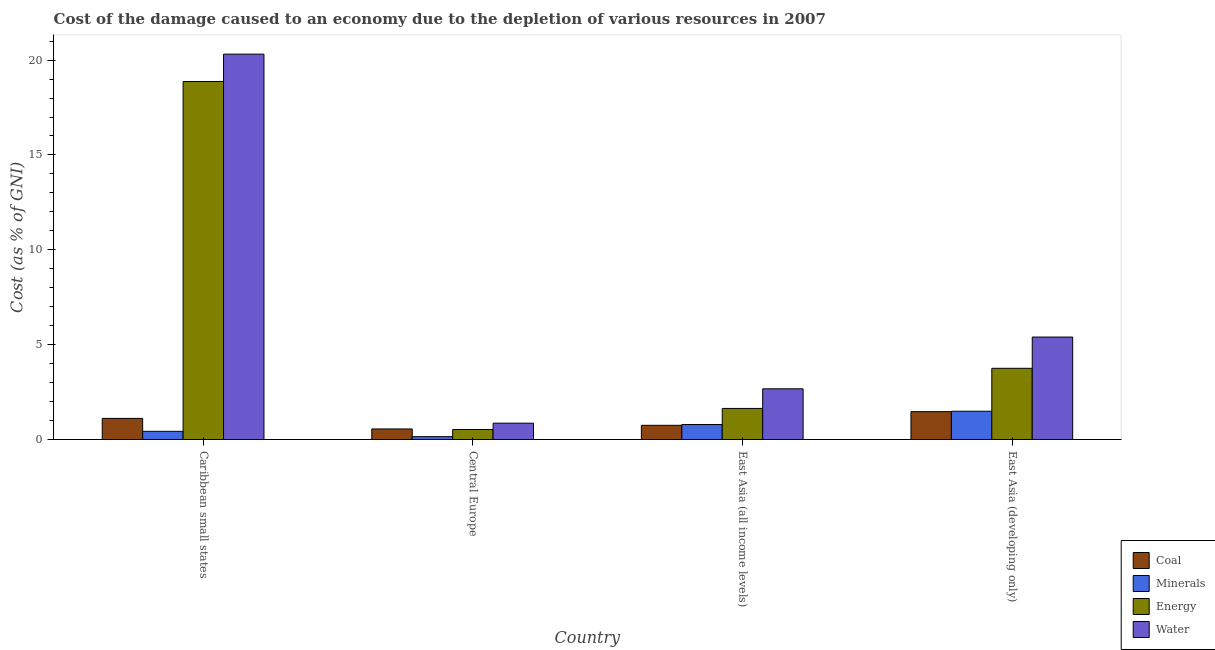How many different coloured bars are there?
Offer a very short reply. 4. How many groups of bars are there?
Offer a terse response. 4. How many bars are there on the 3rd tick from the left?
Your answer should be very brief. 4. What is the label of the 2nd group of bars from the left?
Offer a terse response. Central Europe. In how many cases, is the number of bars for a given country not equal to the number of legend labels?
Ensure brevity in your answer.  0. What is the cost of damage due to depletion of coal in East Asia (developing only)?
Offer a very short reply. 1.47. Across all countries, what is the maximum cost of damage due to depletion of minerals?
Give a very brief answer. 1.49. Across all countries, what is the minimum cost of damage due to depletion of minerals?
Offer a very short reply. 0.15. In which country was the cost of damage due to depletion of coal maximum?
Keep it short and to the point. East Asia (developing only). In which country was the cost of damage due to depletion of water minimum?
Give a very brief answer. Central Europe. What is the total cost of damage due to depletion of coal in the graph?
Give a very brief answer. 3.89. What is the difference between the cost of damage due to depletion of energy in Caribbean small states and that in East Asia (developing only)?
Provide a short and direct response. 15.12. What is the difference between the cost of damage due to depletion of coal in East Asia (developing only) and the cost of damage due to depletion of minerals in Caribbean small states?
Provide a short and direct response. 1.04. What is the average cost of damage due to depletion of energy per country?
Make the answer very short. 6.2. What is the difference between the cost of damage due to depletion of energy and cost of damage due to depletion of minerals in East Asia (developing only)?
Make the answer very short. 2.26. In how many countries, is the cost of damage due to depletion of minerals greater than 20 %?
Provide a succinct answer. 0. What is the ratio of the cost of damage due to depletion of water in Caribbean small states to that in East Asia (developing only)?
Your answer should be very brief. 3.76. Is the difference between the cost of damage due to depletion of water in Central Europe and East Asia (developing only) greater than the difference between the cost of damage due to depletion of coal in Central Europe and East Asia (developing only)?
Offer a very short reply. No. What is the difference between the highest and the second highest cost of damage due to depletion of water?
Ensure brevity in your answer.  14.91. What is the difference between the highest and the lowest cost of damage due to depletion of water?
Give a very brief answer. 19.45. Is the sum of the cost of damage due to depletion of water in Caribbean small states and East Asia (all income levels) greater than the maximum cost of damage due to depletion of coal across all countries?
Give a very brief answer. Yes. Is it the case that in every country, the sum of the cost of damage due to depletion of water and cost of damage due to depletion of coal is greater than the sum of cost of damage due to depletion of energy and cost of damage due to depletion of minerals?
Make the answer very short. No. What does the 4th bar from the left in East Asia (developing only) represents?
Provide a short and direct response. Water. What does the 1st bar from the right in East Asia (developing only) represents?
Make the answer very short. Water. How many countries are there in the graph?
Offer a very short reply. 4. Does the graph contain any zero values?
Your answer should be compact. No. Where does the legend appear in the graph?
Your answer should be very brief. Bottom right. How many legend labels are there?
Provide a succinct answer. 4. How are the legend labels stacked?
Offer a terse response. Vertical. What is the title of the graph?
Make the answer very short. Cost of the damage caused to an economy due to the depletion of various resources in 2007 . What is the label or title of the X-axis?
Your response must be concise. Country. What is the label or title of the Y-axis?
Make the answer very short. Cost (as % of GNI). What is the Cost (as % of GNI) in Coal in Caribbean small states?
Keep it short and to the point. 1.11. What is the Cost (as % of GNI) in Minerals in Caribbean small states?
Your answer should be very brief. 0.43. What is the Cost (as % of GNI) of Energy in Caribbean small states?
Ensure brevity in your answer.  18.87. What is the Cost (as % of GNI) in Water in Caribbean small states?
Make the answer very short. 20.31. What is the Cost (as % of GNI) in Coal in Central Europe?
Give a very brief answer. 0.56. What is the Cost (as % of GNI) in Minerals in Central Europe?
Offer a terse response. 0.15. What is the Cost (as % of GNI) of Energy in Central Europe?
Give a very brief answer. 0.53. What is the Cost (as % of GNI) of Water in Central Europe?
Your answer should be compact. 0.86. What is the Cost (as % of GNI) in Coal in East Asia (all income levels)?
Your answer should be compact. 0.75. What is the Cost (as % of GNI) of Minerals in East Asia (all income levels)?
Offer a terse response. 0.79. What is the Cost (as % of GNI) in Energy in East Asia (all income levels)?
Keep it short and to the point. 1.64. What is the Cost (as % of GNI) in Water in East Asia (all income levels)?
Offer a very short reply. 2.67. What is the Cost (as % of GNI) of Coal in East Asia (developing only)?
Offer a terse response. 1.47. What is the Cost (as % of GNI) of Minerals in East Asia (developing only)?
Offer a very short reply. 1.49. What is the Cost (as % of GNI) of Energy in East Asia (developing only)?
Your answer should be very brief. 3.75. What is the Cost (as % of GNI) in Water in East Asia (developing only)?
Provide a succinct answer. 5.4. Across all countries, what is the maximum Cost (as % of GNI) of Coal?
Offer a very short reply. 1.47. Across all countries, what is the maximum Cost (as % of GNI) of Minerals?
Your response must be concise. 1.49. Across all countries, what is the maximum Cost (as % of GNI) in Energy?
Ensure brevity in your answer.  18.87. Across all countries, what is the maximum Cost (as % of GNI) in Water?
Ensure brevity in your answer.  20.31. Across all countries, what is the minimum Cost (as % of GNI) of Coal?
Keep it short and to the point. 0.56. Across all countries, what is the minimum Cost (as % of GNI) of Minerals?
Ensure brevity in your answer.  0.15. Across all countries, what is the minimum Cost (as % of GNI) of Energy?
Ensure brevity in your answer.  0.53. Across all countries, what is the minimum Cost (as % of GNI) of Water?
Offer a very short reply. 0.86. What is the total Cost (as % of GNI) of Coal in the graph?
Your answer should be very brief. 3.89. What is the total Cost (as % of GNI) in Minerals in the graph?
Your response must be concise. 2.87. What is the total Cost (as % of GNI) in Energy in the graph?
Ensure brevity in your answer.  24.79. What is the total Cost (as % of GNI) in Water in the graph?
Provide a short and direct response. 29.25. What is the difference between the Cost (as % of GNI) in Coal in Caribbean small states and that in Central Europe?
Your answer should be compact. 0.56. What is the difference between the Cost (as % of GNI) in Minerals in Caribbean small states and that in Central Europe?
Provide a short and direct response. 0.28. What is the difference between the Cost (as % of GNI) of Energy in Caribbean small states and that in Central Europe?
Offer a terse response. 18.35. What is the difference between the Cost (as % of GNI) of Water in Caribbean small states and that in Central Europe?
Provide a short and direct response. 19.45. What is the difference between the Cost (as % of GNI) of Coal in Caribbean small states and that in East Asia (all income levels)?
Your answer should be very brief. 0.36. What is the difference between the Cost (as % of GNI) in Minerals in Caribbean small states and that in East Asia (all income levels)?
Make the answer very short. -0.36. What is the difference between the Cost (as % of GNI) in Energy in Caribbean small states and that in East Asia (all income levels)?
Keep it short and to the point. 17.23. What is the difference between the Cost (as % of GNI) in Water in Caribbean small states and that in East Asia (all income levels)?
Your response must be concise. 17.64. What is the difference between the Cost (as % of GNI) of Coal in Caribbean small states and that in East Asia (developing only)?
Provide a succinct answer. -0.36. What is the difference between the Cost (as % of GNI) in Minerals in Caribbean small states and that in East Asia (developing only)?
Give a very brief answer. -1.06. What is the difference between the Cost (as % of GNI) in Energy in Caribbean small states and that in East Asia (developing only)?
Your response must be concise. 15.12. What is the difference between the Cost (as % of GNI) of Water in Caribbean small states and that in East Asia (developing only)?
Offer a very short reply. 14.91. What is the difference between the Cost (as % of GNI) of Coal in Central Europe and that in East Asia (all income levels)?
Your answer should be compact. -0.19. What is the difference between the Cost (as % of GNI) of Minerals in Central Europe and that in East Asia (all income levels)?
Your response must be concise. -0.64. What is the difference between the Cost (as % of GNI) in Energy in Central Europe and that in East Asia (all income levels)?
Your response must be concise. -1.11. What is the difference between the Cost (as % of GNI) in Water in Central Europe and that in East Asia (all income levels)?
Keep it short and to the point. -1.81. What is the difference between the Cost (as % of GNI) in Coal in Central Europe and that in East Asia (developing only)?
Give a very brief answer. -0.91. What is the difference between the Cost (as % of GNI) of Minerals in Central Europe and that in East Asia (developing only)?
Your answer should be compact. -1.34. What is the difference between the Cost (as % of GNI) in Energy in Central Europe and that in East Asia (developing only)?
Offer a terse response. -3.23. What is the difference between the Cost (as % of GNI) in Water in Central Europe and that in East Asia (developing only)?
Give a very brief answer. -4.54. What is the difference between the Cost (as % of GNI) of Coal in East Asia (all income levels) and that in East Asia (developing only)?
Keep it short and to the point. -0.72. What is the difference between the Cost (as % of GNI) of Energy in East Asia (all income levels) and that in East Asia (developing only)?
Your response must be concise. -2.12. What is the difference between the Cost (as % of GNI) of Water in East Asia (all income levels) and that in East Asia (developing only)?
Ensure brevity in your answer.  -2.73. What is the difference between the Cost (as % of GNI) of Coal in Caribbean small states and the Cost (as % of GNI) of Minerals in Central Europe?
Give a very brief answer. 0.96. What is the difference between the Cost (as % of GNI) in Coal in Caribbean small states and the Cost (as % of GNI) in Energy in Central Europe?
Give a very brief answer. 0.59. What is the difference between the Cost (as % of GNI) of Coal in Caribbean small states and the Cost (as % of GNI) of Water in Central Europe?
Your answer should be very brief. 0.25. What is the difference between the Cost (as % of GNI) of Minerals in Caribbean small states and the Cost (as % of GNI) of Energy in Central Europe?
Make the answer very short. -0.1. What is the difference between the Cost (as % of GNI) in Minerals in Caribbean small states and the Cost (as % of GNI) in Water in Central Europe?
Offer a very short reply. -0.43. What is the difference between the Cost (as % of GNI) in Energy in Caribbean small states and the Cost (as % of GNI) in Water in Central Europe?
Your answer should be very brief. 18.01. What is the difference between the Cost (as % of GNI) of Coal in Caribbean small states and the Cost (as % of GNI) of Minerals in East Asia (all income levels)?
Keep it short and to the point. 0.32. What is the difference between the Cost (as % of GNI) of Coal in Caribbean small states and the Cost (as % of GNI) of Energy in East Asia (all income levels)?
Your answer should be very brief. -0.53. What is the difference between the Cost (as % of GNI) of Coal in Caribbean small states and the Cost (as % of GNI) of Water in East Asia (all income levels)?
Offer a terse response. -1.56. What is the difference between the Cost (as % of GNI) of Minerals in Caribbean small states and the Cost (as % of GNI) of Energy in East Asia (all income levels)?
Ensure brevity in your answer.  -1.21. What is the difference between the Cost (as % of GNI) of Minerals in Caribbean small states and the Cost (as % of GNI) of Water in East Asia (all income levels)?
Make the answer very short. -2.24. What is the difference between the Cost (as % of GNI) of Energy in Caribbean small states and the Cost (as % of GNI) of Water in East Asia (all income levels)?
Your answer should be very brief. 16.2. What is the difference between the Cost (as % of GNI) in Coal in Caribbean small states and the Cost (as % of GNI) in Minerals in East Asia (developing only)?
Offer a very short reply. -0.38. What is the difference between the Cost (as % of GNI) in Coal in Caribbean small states and the Cost (as % of GNI) in Energy in East Asia (developing only)?
Offer a terse response. -2.64. What is the difference between the Cost (as % of GNI) in Coal in Caribbean small states and the Cost (as % of GNI) in Water in East Asia (developing only)?
Keep it short and to the point. -4.29. What is the difference between the Cost (as % of GNI) of Minerals in Caribbean small states and the Cost (as % of GNI) of Energy in East Asia (developing only)?
Give a very brief answer. -3.32. What is the difference between the Cost (as % of GNI) of Minerals in Caribbean small states and the Cost (as % of GNI) of Water in East Asia (developing only)?
Your response must be concise. -4.97. What is the difference between the Cost (as % of GNI) in Energy in Caribbean small states and the Cost (as % of GNI) in Water in East Asia (developing only)?
Offer a very short reply. 13.47. What is the difference between the Cost (as % of GNI) of Coal in Central Europe and the Cost (as % of GNI) of Minerals in East Asia (all income levels)?
Make the answer very short. -0.23. What is the difference between the Cost (as % of GNI) of Coal in Central Europe and the Cost (as % of GNI) of Energy in East Asia (all income levels)?
Give a very brief answer. -1.08. What is the difference between the Cost (as % of GNI) of Coal in Central Europe and the Cost (as % of GNI) of Water in East Asia (all income levels)?
Your answer should be compact. -2.12. What is the difference between the Cost (as % of GNI) of Minerals in Central Europe and the Cost (as % of GNI) of Energy in East Asia (all income levels)?
Offer a terse response. -1.49. What is the difference between the Cost (as % of GNI) of Minerals in Central Europe and the Cost (as % of GNI) of Water in East Asia (all income levels)?
Offer a very short reply. -2.52. What is the difference between the Cost (as % of GNI) of Energy in Central Europe and the Cost (as % of GNI) of Water in East Asia (all income levels)?
Provide a succinct answer. -2.15. What is the difference between the Cost (as % of GNI) of Coal in Central Europe and the Cost (as % of GNI) of Minerals in East Asia (developing only)?
Your response must be concise. -0.93. What is the difference between the Cost (as % of GNI) in Coal in Central Europe and the Cost (as % of GNI) in Energy in East Asia (developing only)?
Provide a succinct answer. -3.2. What is the difference between the Cost (as % of GNI) in Coal in Central Europe and the Cost (as % of GNI) in Water in East Asia (developing only)?
Your answer should be compact. -4.84. What is the difference between the Cost (as % of GNI) in Minerals in Central Europe and the Cost (as % of GNI) in Energy in East Asia (developing only)?
Offer a very short reply. -3.6. What is the difference between the Cost (as % of GNI) in Minerals in Central Europe and the Cost (as % of GNI) in Water in East Asia (developing only)?
Your answer should be compact. -5.25. What is the difference between the Cost (as % of GNI) of Energy in Central Europe and the Cost (as % of GNI) of Water in East Asia (developing only)?
Give a very brief answer. -4.87. What is the difference between the Cost (as % of GNI) in Coal in East Asia (all income levels) and the Cost (as % of GNI) in Minerals in East Asia (developing only)?
Your answer should be compact. -0.74. What is the difference between the Cost (as % of GNI) in Coal in East Asia (all income levels) and the Cost (as % of GNI) in Energy in East Asia (developing only)?
Give a very brief answer. -3.01. What is the difference between the Cost (as % of GNI) of Coal in East Asia (all income levels) and the Cost (as % of GNI) of Water in East Asia (developing only)?
Give a very brief answer. -4.65. What is the difference between the Cost (as % of GNI) in Minerals in East Asia (all income levels) and the Cost (as % of GNI) in Energy in East Asia (developing only)?
Keep it short and to the point. -2.96. What is the difference between the Cost (as % of GNI) of Minerals in East Asia (all income levels) and the Cost (as % of GNI) of Water in East Asia (developing only)?
Make the answer very short. -4.61. What is the difference between the Cost (as % of GNI) of Energy in East Asia (all income levels) and the Cost (as % of GNI) of Water in East Asia (developing only)?
Your answer should be very brief. -3.76. What is the average Cost (as % of GNI) of Coal per country?
Provide a short and direct response. 0.97. What is the average Cost (as % of GNI) of Minerals per country?
Keep it short and to the point. 0.72. What is the average Cost (as % of GNI) of Energy per country?
Your answer should be very brief. 6.2. What is the average Cost (as % of GNI) of Water per country?
Make the answer very short. 7.31. What is the difference between the Cost (as % of GNI) of Coal and Cost (as % of GNI) of Minerals in Caribbean small states?
Offer a terse response. 0.68. What is the difference between the Cost (as % of GNI) in Coal and Cost (as % of GNI) in Energy in Caribbean small states?
Keep it short and to the point. -17.76. What is the difference between the Cost (as % of GNI) of Coal and Cost (as % of GNI) of Water in Caribbean small states?
Provide a short and direct response. -19.2. What is the difference between the Cost (as % of GNI) in Minerals and Cost (as % of GNI) in Energy in Caribbean small states?
Give a very brief answer. -18.44. What is the difference between the Cost (as % of GNI) in Minerals and Cost (as % of GNI) in Water in Caribbean small states?
Your answer should be compact. -19.88. What is the difference between the Cost (as % of GNI) in Energy and Cost (as % of GNI) in Water in Caribbean small states?
Provide a short and direct response. -1.44. What is the difference between the Cost (as % of GNI) of Coal and Cost (as % of GNI) of Minerals in Central Europe?
Offer a very short reply. 0.41. What is the difference between the Cost (as % of GNI) in Coal and Cost (as % of GNI) in Energy in Central Europe?
Offer a very short reply. 0.03. What is the difference between the Cost (as % of GNI) in Coal and Cost (as % of GNI) in Water in Central Europe?
Give a very brief answer. -0.3. What is the difference between the Cost (as % of GNI) in Minerals and Cost (as % of GNI) in Energy in Central Europe?
Your answer should be compact. -0.38. What is the difference between the Cost (as % of GNI) in Minerals and Cost (as % of GNI) in Water in Central Europe?
Provide a succinct answer. -0.71. What is the difference between the Cost (as % of GNI) in Energy and Cost (as % of GNI) in Water in Central Europe?
Keep it short and to the point. -0.33. What is the difference between the Cost (as % of GNI) of Coal and Cost (as % of GNI) of Minerals in East Asia (all income levels)?
Give a very brief answer. -0.04. What is the difference between the Cost (as % of GNI) in Coal and Cost (as % of GNI) in Energy in East Asia (all income levels)?
Offer a very short reply. -0.89. What is the difference between the Cost (as % of GNI) in Coal and Cost (as % of GNI) in Water in East Asia (all income levels)?
Your answer should be compact. -1.93. What is the difference between the Cost (as % of GNI) in Minerals and Cost (as % of GNI) in Energy in East Asia (all income levels)?
Ensure brevity in your answer.  -0.85. What is the difference between the Cost (as % of GNI) of Minerals and Cost (as % of GNI) of Water in East Asia (all income levels)?
Offer a terse response. -1.88. What is the difference between the Cost (as % of GNI) of Energy and Cost (as % of GNI) of Water in East Asia (all income levels)?
Your answer should be very brief. -1.03. What is the difference between the Cost (as % of GNI) in Coal and Cost (as % of GNI) in Minerals in East Asia (developing only)?
Ensure brevity in your answer.  -0.02. What is the difference between the Cost (as % of GNI) of Coal and Cost (as % of GNI) of Energy in East Asia (developing only)?
Provide a succinct answer. -2.28. What is the difference between the Cost (as % of GNI) of Coal and Cost (as % of GNI) of Water in East Asia (developing only)?
Offer a terse response. -3.93. What is the difference between the Cost (as % of GNI) of Minerals and Cost (as % of GNI) of Energy in East Asia (developing only)?
Keep it short and to the point. -2.26. What is the difference between the Cost (as % of GNI) in Minerals and Cost (as % of GNI) in Water in East Asia (developing only)?
Your response must be concise. -3.91. What is the difference between the Cost (as % of GNI) of Energy and Cost (as % of GNI) of Water in East Asia (developing only)?
Keep it short and to the point. -1.65. What is the ratio of the Cost (as % of GNI) in Coal in Caribbean small states to that in Central Europe?
Your response must be concise. 2. What is the ratio of the Cost (as % of GNI) in Minerals in Caribbean small states to that in Central Europe?
Provide a succinct answer. 2.86. What is the ratio of the Cost (as % of GNI) of Energy in Caribbean small states to that in Central Europe?
Your response must be concise. 35.78. What is the ratio of the Cost (as % of GNI) of Water in Caribbean small states to that in Central Europe?
Ensure brevity in your answer.  23.59. What is the ratio of the Cost (as % of GNI) of Coal in Caribbean small states to that in East Asia (all income levels)?
Your answer should be very brief. 1.49. What is the ratio of the Cost (as % of GNI) of Minerals in Caribbean small states to that in East Asia (all income levels)?
Make the answer very short. 0.55. What is the ratio of the Cost (as % of GNI) of Energy in Caribbean small states to that in East Asia (all income levels)?
Provide a short and direct response. 11.52. What is the ratio of the Cost (as % of GNI) in Water in Caribbean small states to that in East Asia (all income levels)?
Make the answer very short. 7.6. What is the ratio of the Cost (as % of GNI) in Coal in Caribbean small states to that in East Asia (developing only)?
Offer a very short reply. 0.76. What is the ratio of the Cost (as % of GNI) of Minerals in Caribbean small states to that in East Asia (developing only)?
Your response must be concise. 0.29. What is the ratio of the Cost (as % of GNI) of Energy in Caribbean small states to that in East Asia (developing only)?
Keep it short and to the point. 5.03. What is the ratio of the Cost (as % of GNI) in Water in Caribbean small states to that in East Asia (developing only)?
Your response must be concise. 3.76. What is the ratio of the Cost (as % of GNI) in Coal in Central Europe to that in East Asia (all income levels)?
Offer a terse response. 0.74. What is the ratio of the Cost (as % of GNI) of Minerals in Central Europe to that in East Asia (all income levels)?
Keep it short and to the point. 0.19. What is the ratio of the Cost (as % of GNI) in Energy in Central Europe to that in East Asia (all income levels)?
Your response must be concise. 0.32. What is the ratio of the Cost (as % of GNI) of Water in Central Europe to that in East Asia (all income levels)?
Keep it short and to the point. 0.32. What is the ratio of the Cost (as % of GNI) of Coal in Central Europe to that in East Asia (developing only)?
Make the answer very short. 0.38. What is the ratio of the Cost (as % of GNI) in Minerals in Central Europe to that in East Asia (developing only)?
Make the answer very short. 0.1. What is the ratio of the Cost (as % of GNI) of Energy in Central Europe to that in East Asia (developing only)?
Ensure brevity in your answer.  0.14. What is the ratio of the Cost (as % of GNI) of Water in Central Europe to that in East Asia (developing only)?
Ensure brevity in your answer.  0.16. What is the ratio of the Cost (as % of GNI) of Coal in East Asia (all income levels) to that in East Asia (developing only)?
Provide a succinct answer. 0.51. What is the ratio of the Cost (as % of GNI) of Minerals in East Asia (all income levels) to that in East Asia (developing only)?
Give a very brief answer. 0.53. What is the ratio of the Cost (as % of GNI) of Energy in East Asia (all income levels) to that in East Asia (developing only)?
Provide a short and direct response. 0.44. What is the ratio of the Cost (as % of GNI) in Water in East Asia (all income levels) to that in East Asia (developing only)?
Ensure brevity in your answer.  0.49. What is the difference between the highest and the second highest Cost (as % of GNI) in Coal?
Offer a very short reply. 0.36. What is the difference between the highest and the second highest Cost (as % of GNI) in Energy?
Your answer should be compact. 15.12. What is the difference between the highest and the second highest Cost (as % of GNI) in Water?
Ensure brevity in your answer.  14.91. What is the difference between the highest and the lowest Cost (as % of GNI) in Coal?
Provide a succinct answer. 0.91. What is the difference between the highest and the lowest Cost (as % of GNI) of Minerals?
Offer a very short reply. 1.34. What is the difference between the highest and the lowest Cost (as % of GNI) in Energy?
Make the answer very short. 18.35. What is the difference between the highest and the lowest Cost (as % of GNI) of Water?
Make the answer very short. 19.45. 